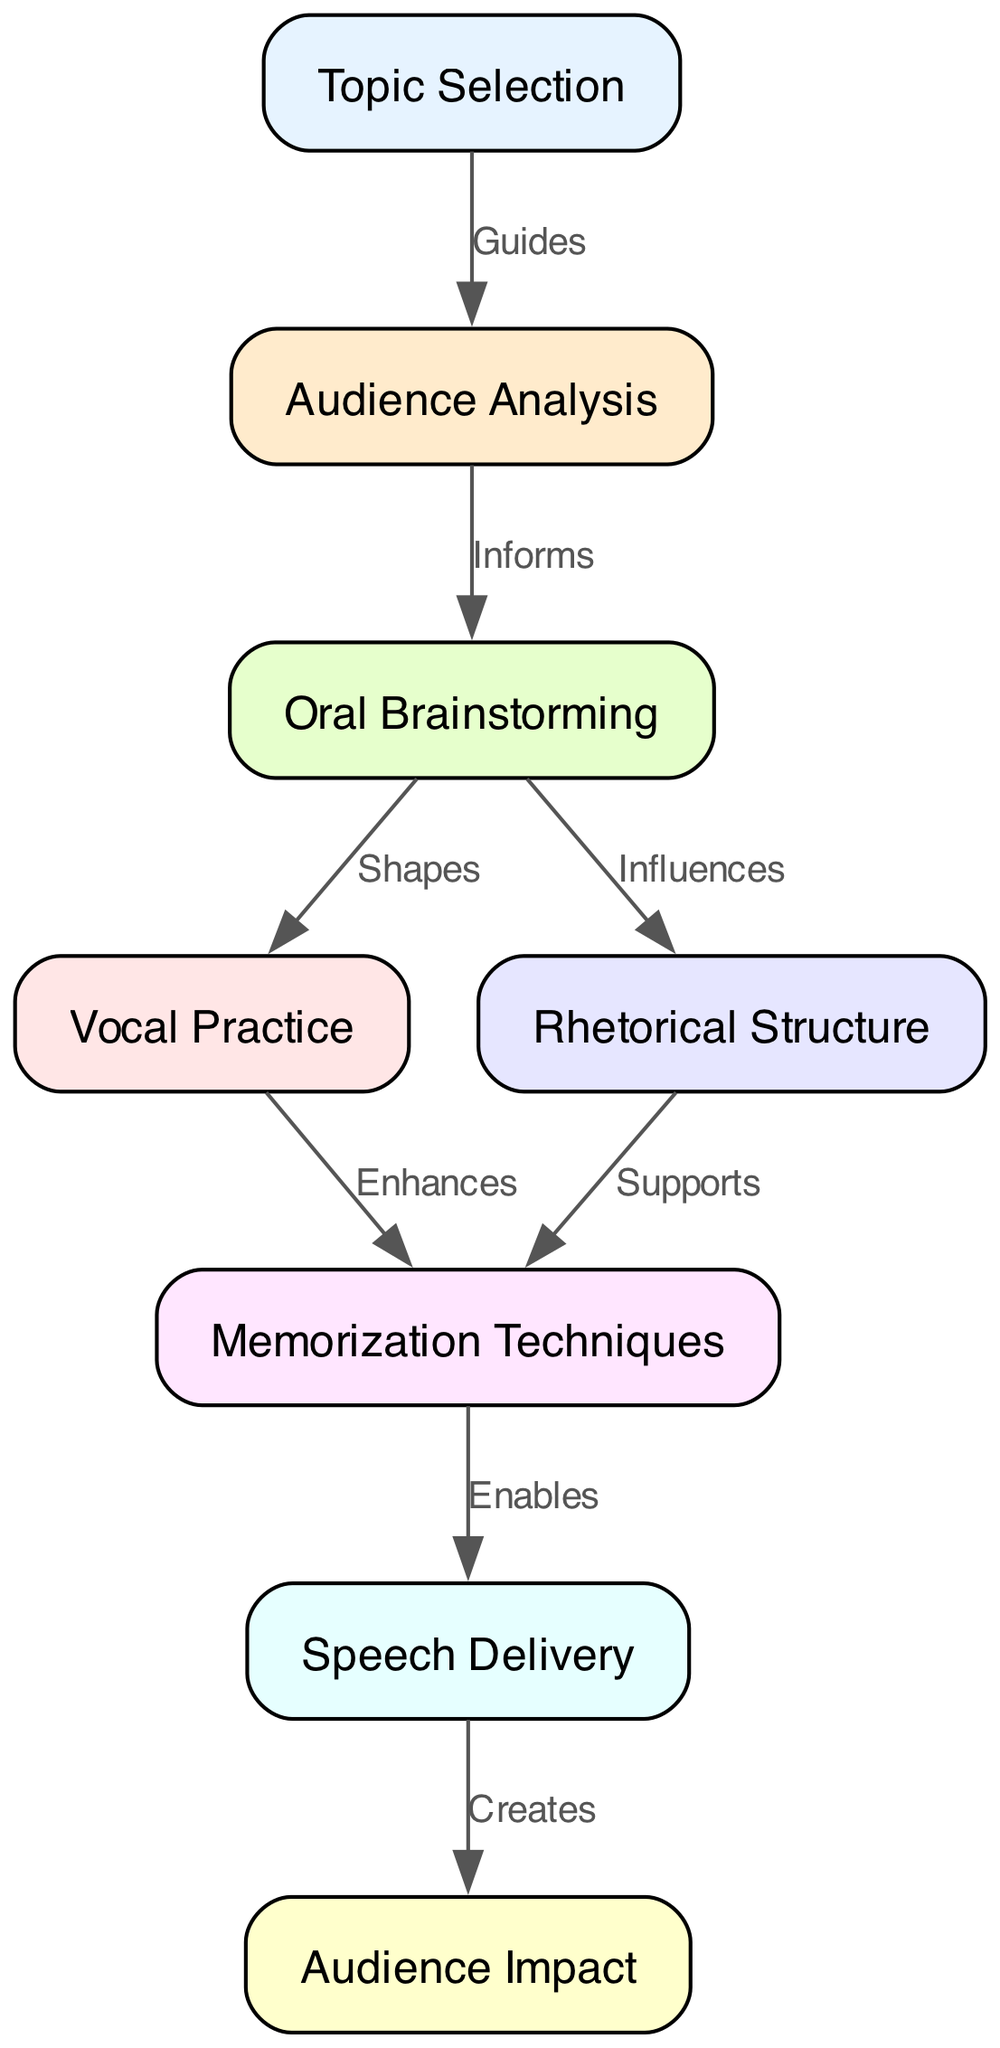What is the first step in the persuasive speech process? The first node in the diagram is "Topic Selection," which indicates that this is the initial step in developing a persuasive speech.
Answer: Topic Selection How many nodes are present in the diagram? By counting the listed nodes in the diagram, there are eight nodes that represent different steps in the speech development process.
Answer: Eight What relationship is indicated between "Audience Analysis" and "Oral Brainstorming"? The edge between these two nodes shows that "Audience Analysis" informs "Oral Brainstorming," indicating a one-way relationship where audience understanding contributes to idea generation.
Answer: Informs Which step directly leads to "Speech Delivery"? The diagram shows that "Memorization Techniques" directly enables "Speech Delivery," meaning that the application of memorization skills is critical for successful delivery of the speech.
Answer: Memorization Techniques What is the last step that results from "Speech Delivery"? According to the edges in the diagram, "Speech Delivery" creates "Audience Impact," demonstrating that the effective delivery of a speech ultimately affects how the audience perceives and responds to it.
Answer: Audience Impact What step influences both "Vocal Practice" and "Rhetorical Structure"? The step "Oral Brainstorming" influences both "Vocal Practice" and "Rhetorical Structure," indicating its role in shaping both the delivery style and the overall structure of the speech.
Answer: Oral Brainstorming How many edges are there in total in the process flow chart? Counting all connections (edges) between the nodes, there are seven edges indicating the relationships and flow of the process steps in the speech development.
Answer: Seven Which step enhances another step within the speech process? "Vocal Practice" enhances "Memorization Techniques," showing that practicing vocal delivery improves the effectiveness of memorization when preparing the speech.
Answer: Vocal Practice 